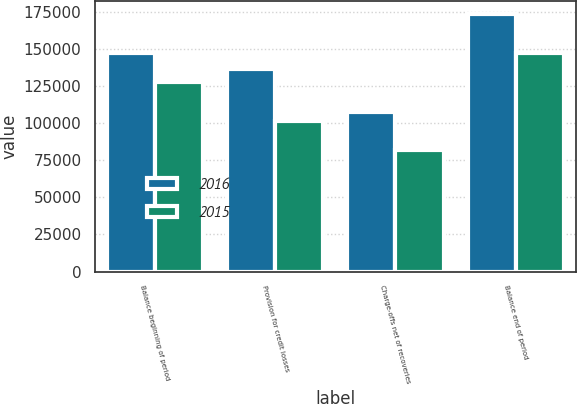Convert chart to OTSL. <chart><loc_0><loc_0><loc_500><loc_500><stacked_bar_chart><ecel><fcel>Balance beginning of period<fcel>Provision for credit losses<fcel>Charge-offs net of recoveries<fcel>Balance end of period<nl><fcel>2016<fcel>147178<fcel>136617<fcel>107161<fcel>173343<nl><fcel>2015<fcel>127364<fcel>101345<fcel>81531<fcel>147178<nl></chart> 